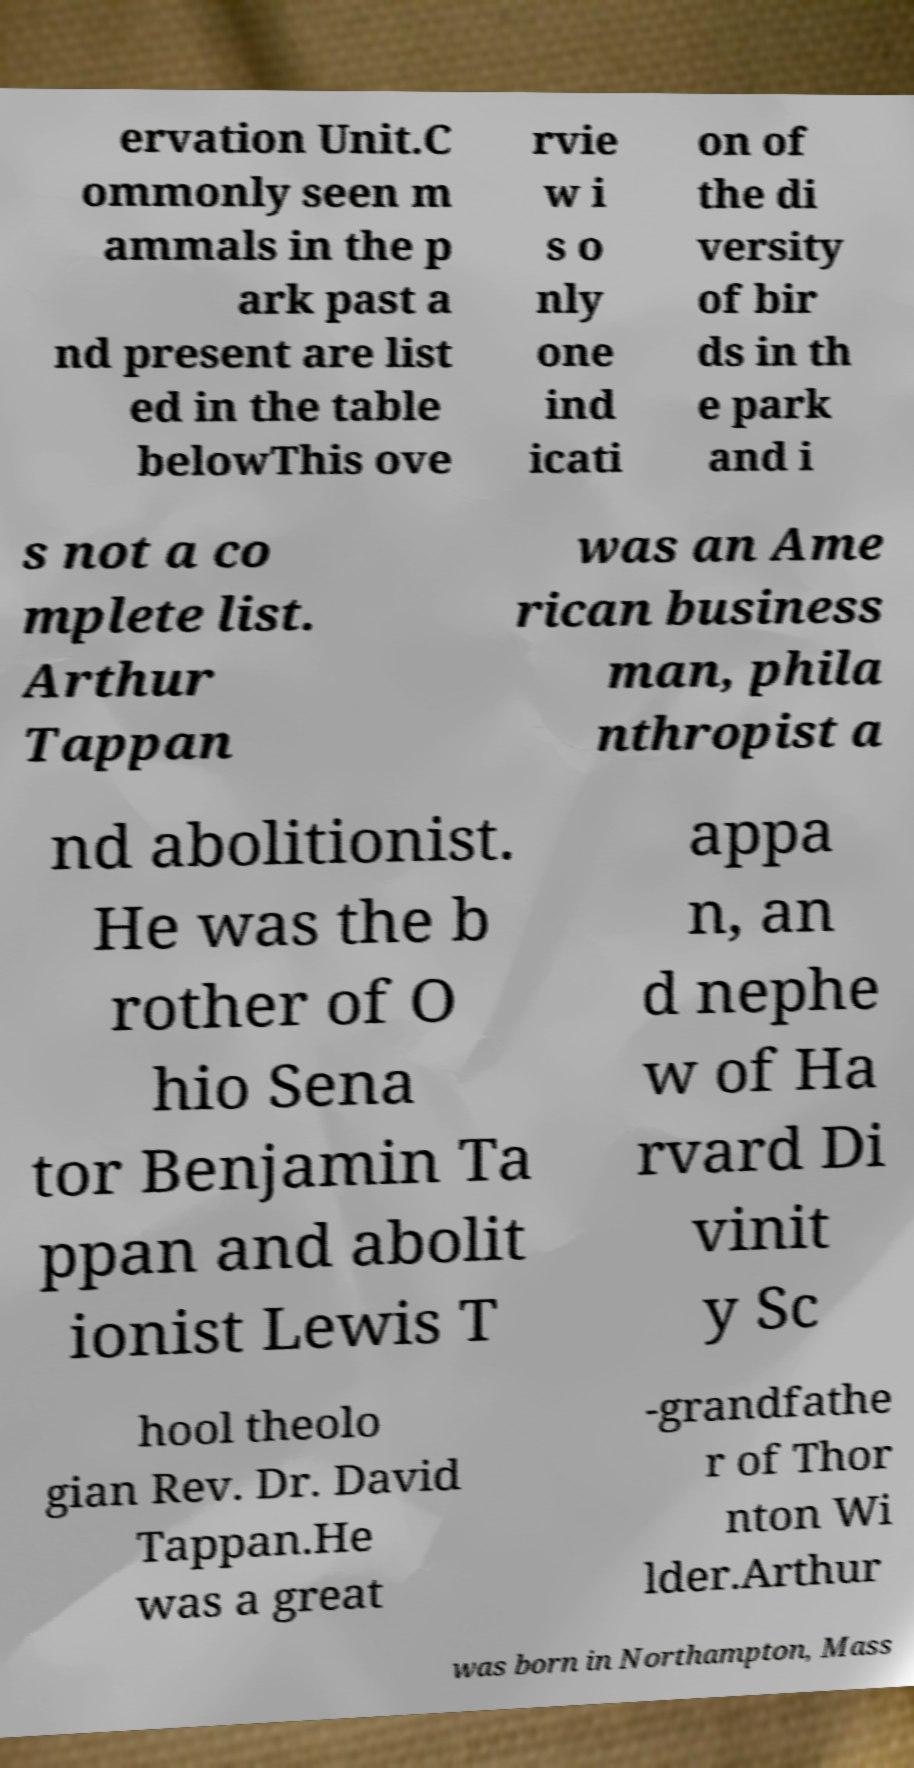Could you assist in decoding the text presented in this image and type it out clearly? ervation Unit.C ommonly seen m ammals in the p ark past a nd present are list ed in the table belowThis ove rvie w i s o nly one ind icati on of the di versity of bir ds in th e park and i s not a co mplete list. Arthur Tappan was an Ame rican business man, phila nthropist a nd abolitionist. He was the b rother of O hio Sena tor Benjamin Ta ppan and abolit ionist Lewis T appa n, an d nephe w of Ha rvard Di vinit y Sc hool theolo gian Rev. Dr. David Tappan.He was a great -grandfathe r of Thor nton Wi lder.Arthur was born in Northampton, Mass 